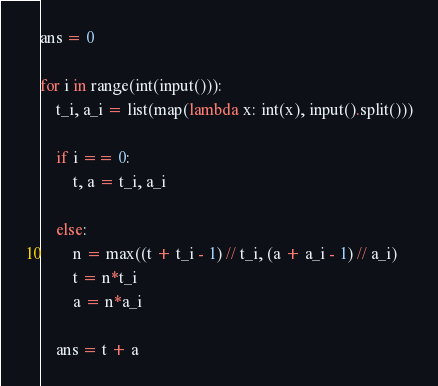Convert code to text. <code><loc_0><loc_0><loc_500><loc_500><_Python_>ans = 0
 
for i in range(int(input())):
    t_i, a_i = list(map(lambda x: int(x), input().split()))
 
    if i == 0:
        t, a = t_i, a_i
 
    else:
        n = max((t + t_i - 1) // t_i, (a + a_i - 1) // a_i)
        t = n*t_i
        a = n*a_i
 
    ans = t + a</code> 